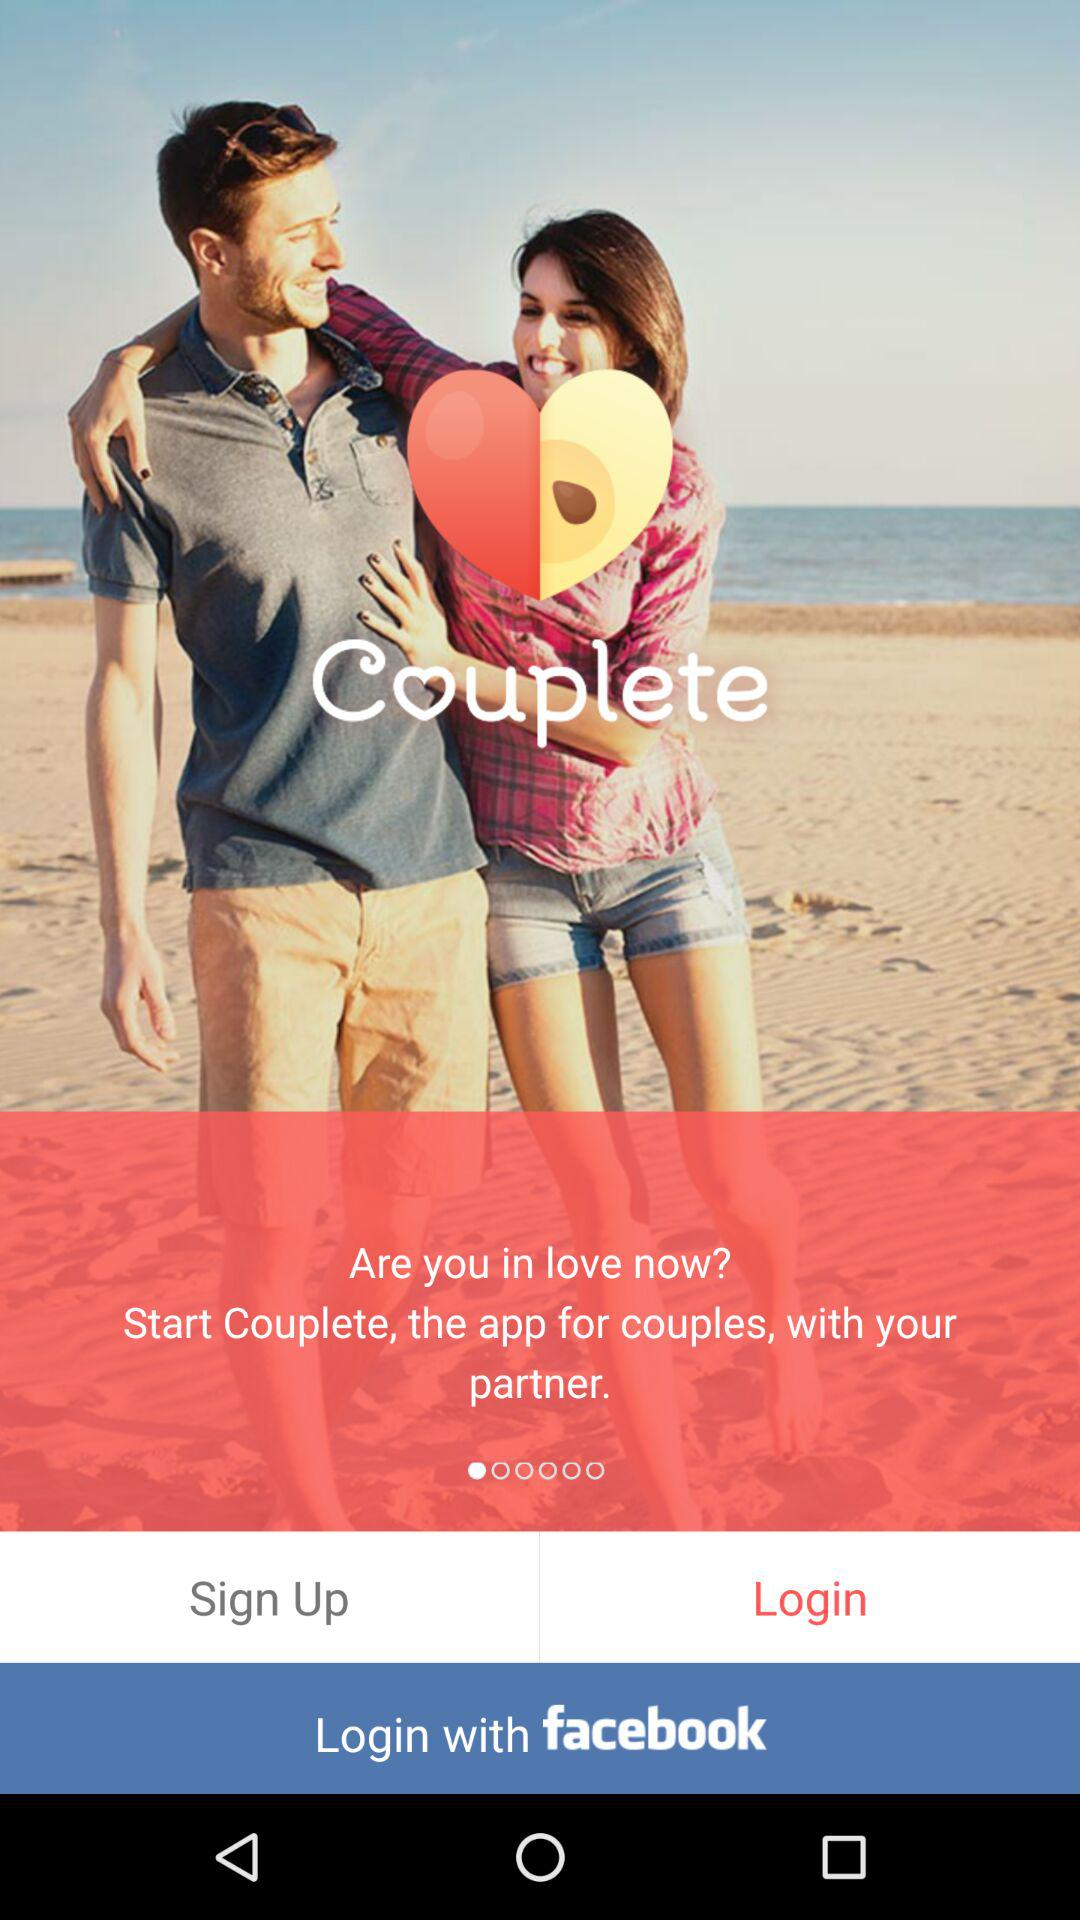Through what account login can be done? We can log in through Facebook. 